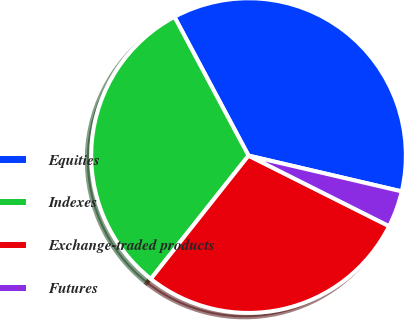Convert chart to OTSL. <chart><loc_0><loc_0><loc_500><loc_500><pie_chart><fcel>Equities<fcel>Indexes<fcel>Exchange-traded products<fcel>Futures<nl><fcel>36.46%<fcel>31.53%<fcel>28.26%<fcel>3.75%<nl></chart> 